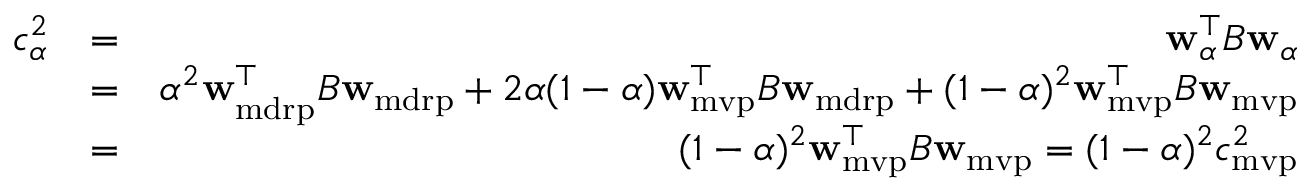Convert formula to latex. <formula><loc_0><loc_0><loc_500><loc_500>\begin{array} { r l r } { c _ { \alpha } ^ { 2 } } & { = } & { { w } _ { \alpha } ^ { \top } B { w } _ { \alpha } } \\ & { = } & { \alpha ^ { 2 } { w } _ { m d r p } ^ { \top } B { w } _ { m d r p } + 2 \alpha ( 1 - \alpha ) { w } _ { m v p } ^ { \top } B { w } _ { m d r p } + ( 1 - \alpha ) ^ { 2 } { w } _ { m v p } ^ { \top } B { w } _ { m v p } } \\ & { = } & { ( 1 - \alpha ) ^ { 2 } { w } _ { m v p } ^ { \top } B { w } _ { m v p } = ( 1 - \alpha ) ^ { 2 } c _ { m v p } ^ { 2 } } \end{array}</formula> 